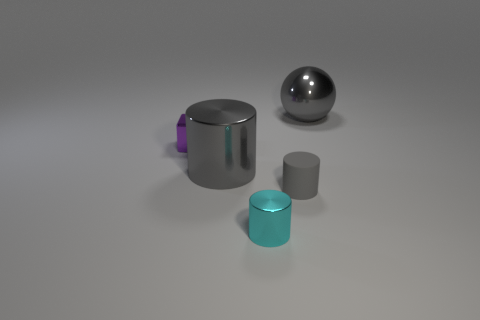Do the rubber cylinder and the large ball have the same color?
Ensure brevity in your answer.  Yes. What number of other objects are the same material as the ball?
Ensure brevity in your answer.  3. What is the material of the gray thing that is the same size as the purple metallic block?
Offer a very short reply. Rubber. Is the number of small things that are in front of the cyan cylinder less than the number of tiny blue blocks?
Provide a short and direct response. No. There is a large gray metal object that is on the left side of the big gray shiny object that is behind the gray metallic thing in front of the purple shiny thing; what shape is it?
Make the answer very short. Cylinder. How big is the object that is behind the metal cube?
Keep it short and to the point. Large. There is a purple shiny object that is the same size as the matte cylinder; what shape is it?
Offer a very short reply. Cube. What number of things are either green rubber blocks or metal things right of the purple object?
Provide a short and direct response. 3. There is a gray cylinder on the right side of the gray metal object in front of the shiny block; how many small gray cylinders are behind it?
Give a very brief answer. 0. There is a small cylinder that is the same material as the small purple thing; what color is it?
Give a very brief answer. Cyan. 